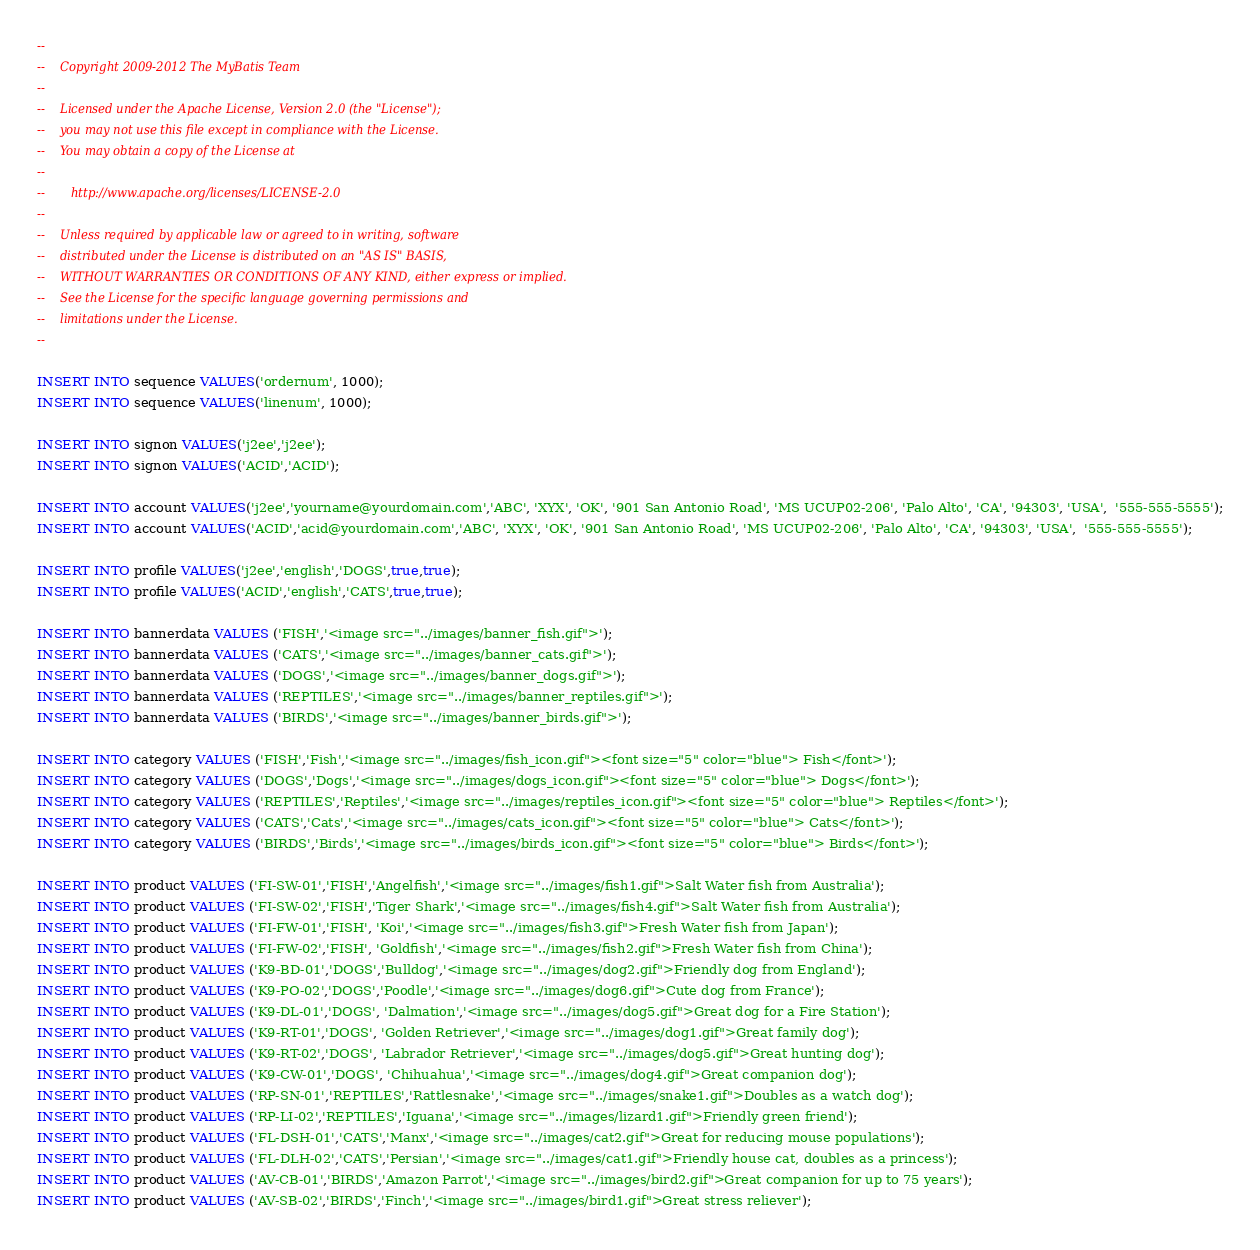Convert code to text. <code><loc_0><loc_0><loc_500><loc_500><_SQL_>--
--    Copyright 2009-2012 The MyBatis Team
--
--    Licensed under the Apache License, Version 2.0 (the "License");
--    you may not use this file except in compliance with the License.
--    You may obtain a copy of the License at
--
--       http://www.apache.org/licenses/LICENSE-2.0
--
--    Unless required by applicable law or agreed to in writing, software
--    distributed under the License is distributed on an "AS IS" BASIS,
--    WITHOUT WARRANTIES OR CONDITIONS OF ANY KIND, either express or implied.
--    See the License for the specific language governing permissions and
--    limitations under the License.
--

INSERT INTO sequence VALUES('ordernum', 1000);
INSERT INTO sequence VALUES('linenum', 1000);

INSERT INTO signon VALUES('j2ee','j2ee');
INSERT INTO signon VALUES('ACID','ACID');

INSERT INTO account VALUES('j2ee','yourname@yourdomain.com','ABC', 'XYX', 'OK', '901 San Antonio Road', 'MS UCUP02-206', 'Palo Alto', 'CA', '94303', 'USA',  '555-555-5555');
INSERT INTO account VALUES('ACID','acid@yourdomain.com','ABC', 'XYX', 'OK', '901 San Antonio Road', 'MS UCUP02-206', 'Palo Alto', 'CA', '94303', 'USA',  '555-555-5555');

INSERT INTO profile VALUES('j2ee','english','DOGS',true,true);
INSERT INTO profile VALUES('ACID','english','CATS',true,true);

INSERT INTO bannerdata VALUES ('FISH','<image src="../images/banner_fish.gif">');
INSERT INTO bannerdata VALUES ('CATS','<image src="../images/banner_cats.gif">');
INSERT INTO bannerdata VALUES ('DOGS','<image src="../images/banner_dogs.gif">');
INSERT INTO bannerdata VALUES ('REPTILES','<image src="../images/banner_reptiles.gif">');
INSERT INTO bannerdata VALUES ('BIRDS','<image src="../images/banner_birds.gif">');

INSERT INTO category VALUES ('FISH','Fish','<image src="../images/fish_icon.gif"><font size="5" color="blue"> Fish</font>');
INSERT INTO category VALUES ('DOGS','Dogs','<image src="../images/dogs_icon.gif"><font size="5" color="blue"> Dogs</font>');
INSERT INTO category VALUES ('REPTILES','Reptiles','<image src="../images/reptiles_icon.gif"><font size="5" color="blue"> Reptiles</font>');
INSERT INTO category VALUES ('CATS','Cats','<image src="../images/cats_icon.gif"><font size="5" color="blue"> Cats</font>');
INSERT INTO category VALUES ('BIRDS','Birds','<image src="../images/birds_icon.gif"><font size="5" color="blue"> Birds</font>');

INSERT INTO product VALUES ('FI-SW-01','FISH','Angelfish','<image src="../images/fish1.gif">Salt Water fish from Australia');
INSERT INTO product VALUES ('FI-SW-02','FISH','Tiger Shark','<image src="../images/fish4.gif">Salt Water fish from Australia');
INSERT INTO product VALUES ('FI-FW-01','FISH', 'Koi','<image src="../images/fish3.gif">Fresh Water fish from Japan');
INSERT INTO product VALUES ('FI-FW-02','FISH', 'Goldfish','<image src="../images/fish2.gif">Fresh Water fish from China');
INSERT INTO product VALUES ('K9-BD-01','DOGS','Bulldog','<image src="../images/dog2.gif">Friendly dog from England');
INSERT INTO product VALUES ('K9-PO-02','DOGS','Poodle','<image src="../images/dog6.gif">Cute dog from France');
INSERT INTO product VALUES ('K9-DL-01','DOGS', 'Dalmation','<image src="../images/dog5.gif">Great dog for a Fire Station');
INSERT INTO product VALUES ('K9-RT-01','DOGS', 'Golden Retriever','<image src="../images/dog1.gif">Great family dog');
INSERT INTO product VALUES ('K9-RT-02','DOGS', 'Labrador Retriever','<image src="../images/dog5.gif">Great hunting dog');
INSERT INTO product VALUES ('K9-CW-01','DOGS', 'Chihuahua','<image src="../images/dog4.gif">Great companion dog');
INSERT INTO product VALUES ('RP-SN-01','REPTILES','Rattlesnake','<image src="../images/snake1.gif">Doubles as a watch dog');
INSERT INTO product VALUES ('RP-LI-02','REPTILES','Iguana','<image src="../images/lizard1.gif">Friendly green friend');
INSERT INTO product VALUES ('FL-DSH-01','CATS','Manx','<image src="../images/cat2.gif">Great for reducing mouse populations');
INSERT INTO product VALUES ('FL-DLH-02','CATS','Persian','<image src="../images/cat1.gif">Friendly house cat, doubles as a princess');
INSERT INTO product VALUES ('AV-CB-01','BIRDS','Amazon Parrot','<image src="../images/bird2.gif">Great companion for up to 75 years');
INSERT INTO product VALUES ('AV-SB-02','BIRDS','Finch','<image src="../images/bird1.gif">Great stress reliever');
</code> 